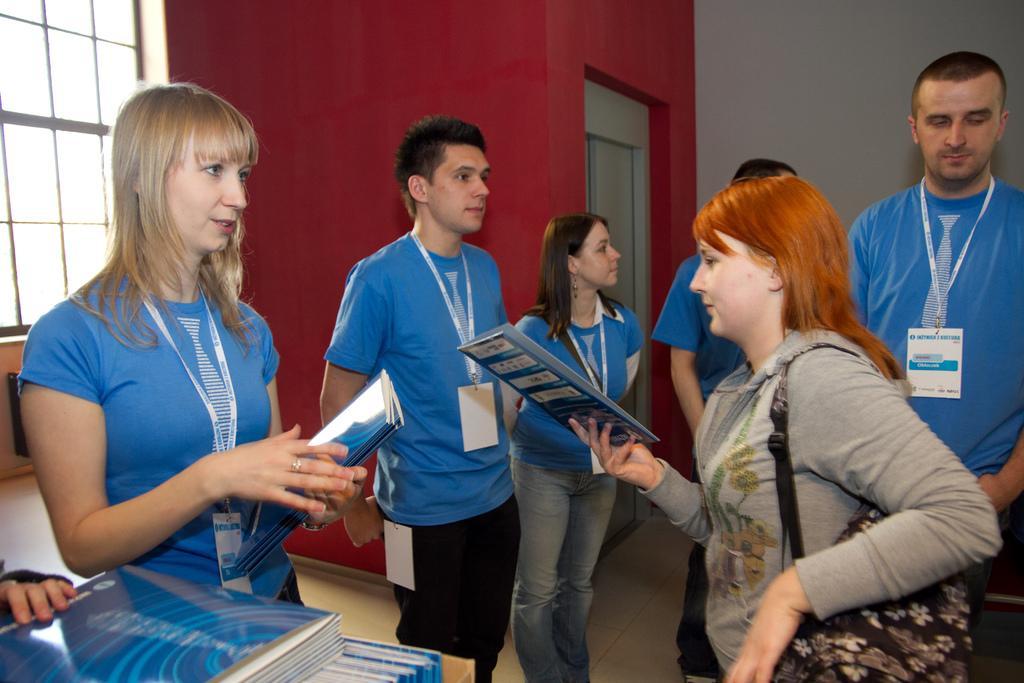Could you give a brief overview of what you see in this image? In this image there are group of people standing , two persons are holding books, there are books on the object , and in the background there is a wall and a window. 